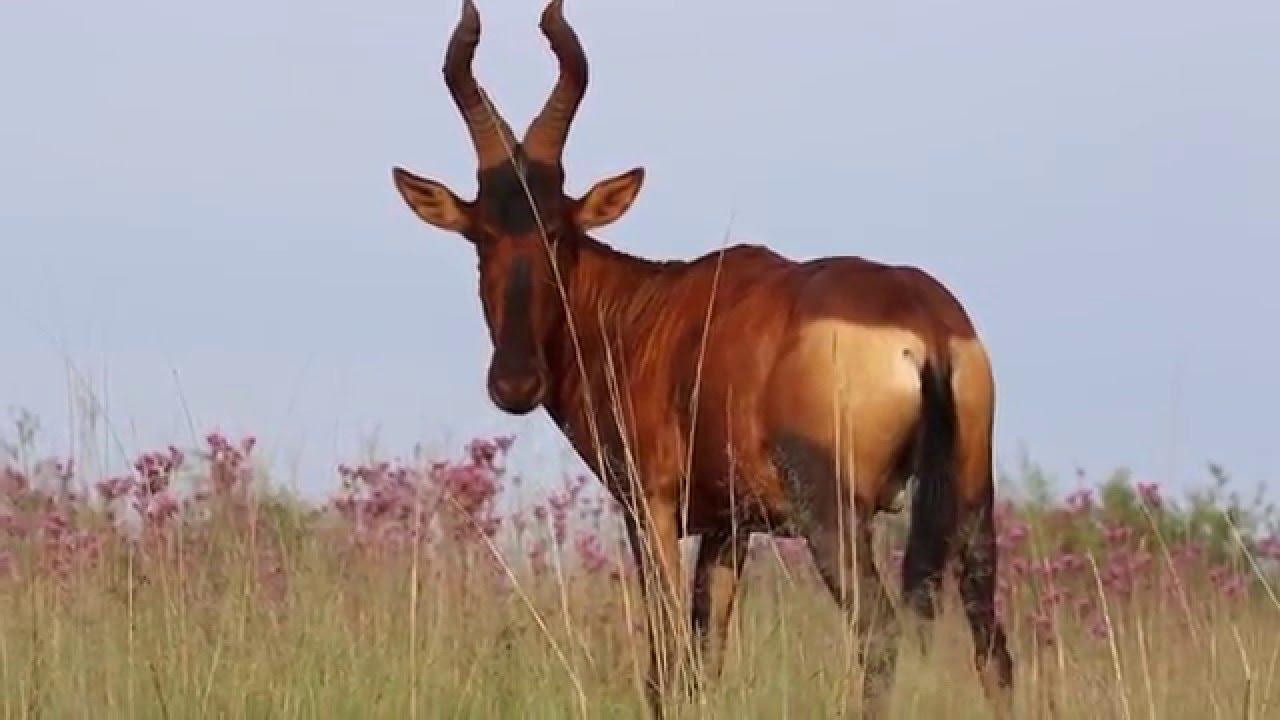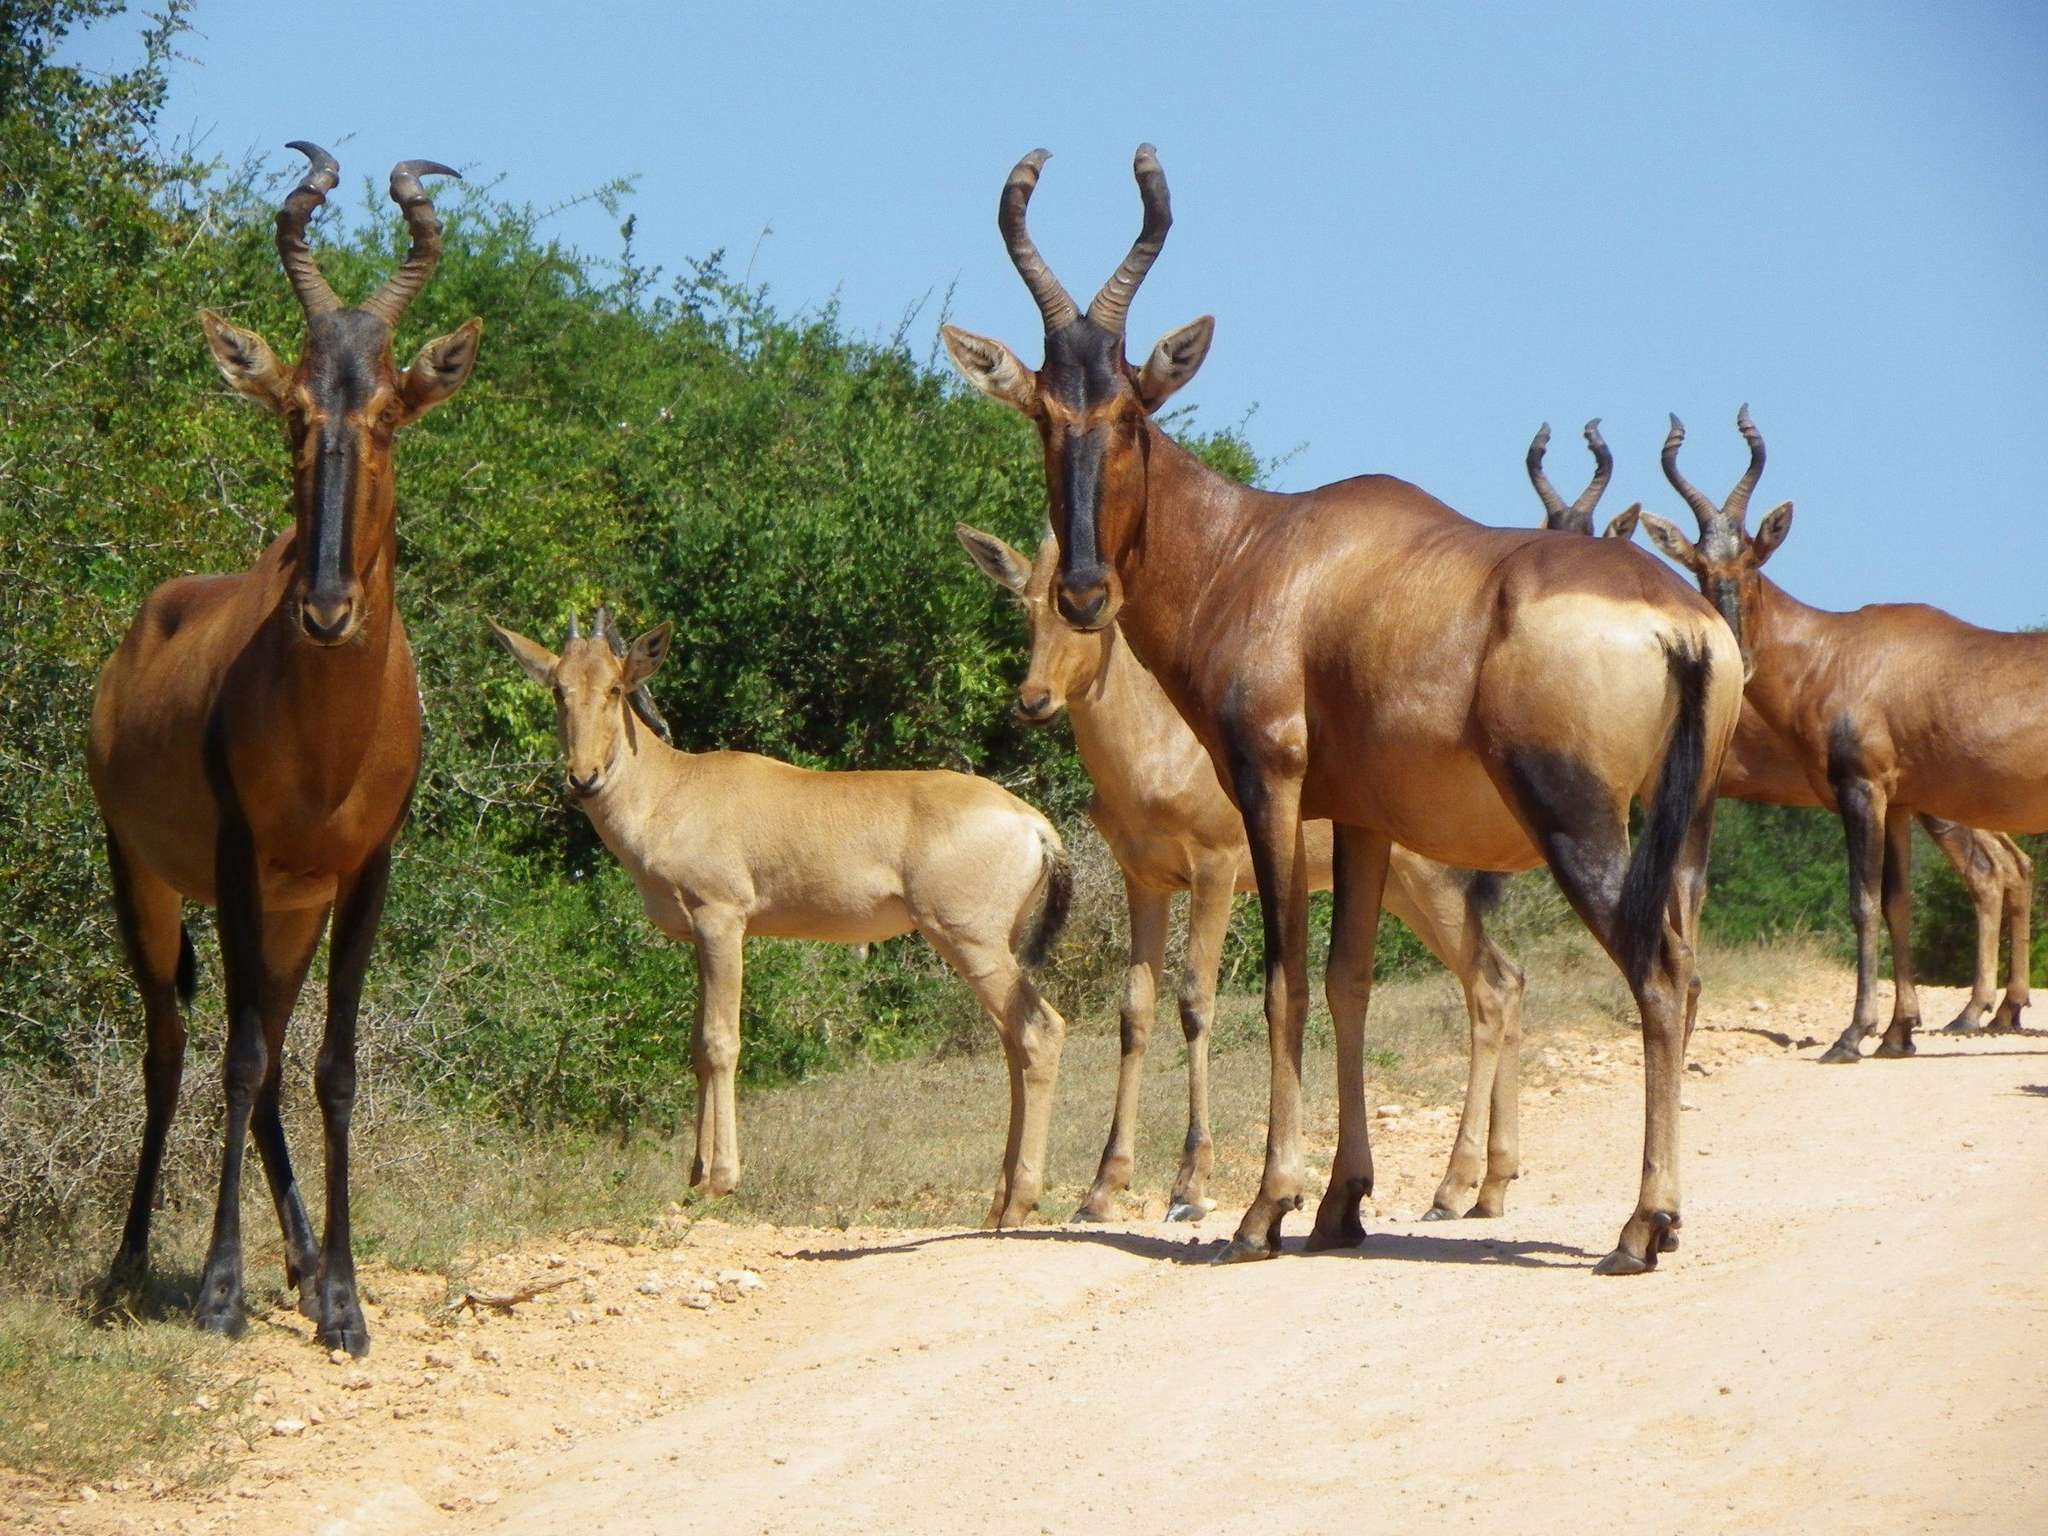The first image is the image on the left, the second image is the image on the right. Given the left and right images, does the statement "At least one live ibex is standing in the grass and weeds." hold true? Answer yes or no. Yes. The first image is the image on the left, the second image is the image on the right. Assess this claim about the two images: "An image shows a hunter holding a rifle crouched behind a downed horned animal with its body facing leftward and its head turned forward, nose on the ground.". Correct or not? Answer yes or no. No. 